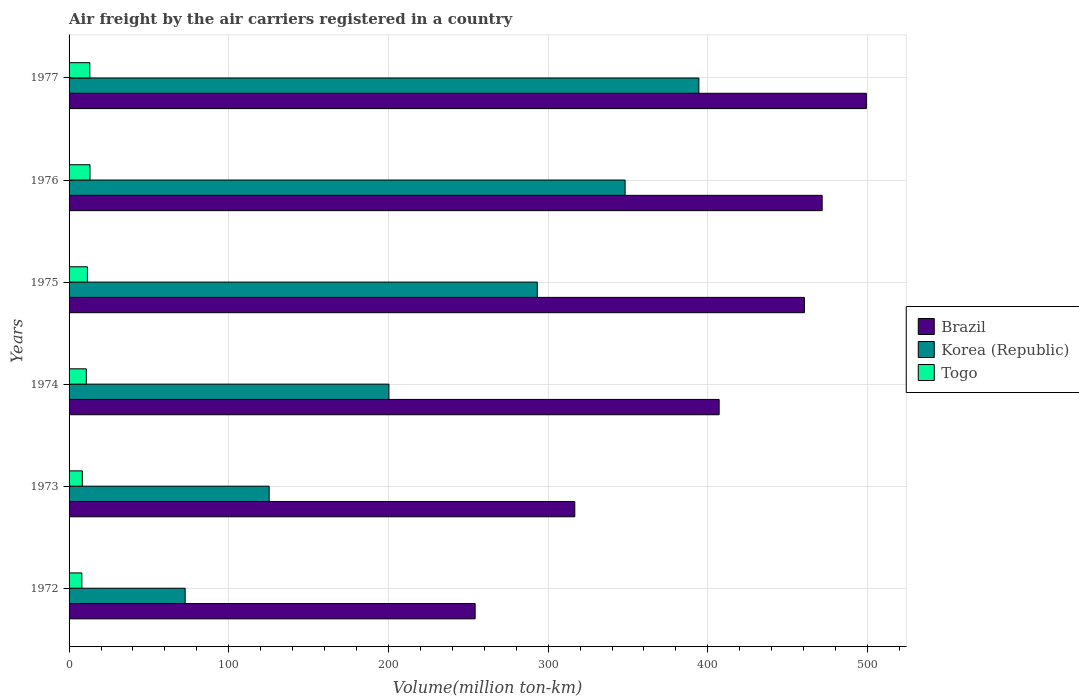How many bars are there on the 4th tick from the top?
Ensure brevity in your answer.  3. How many bars are there on the 3rd tick from the bottom?
Your answer should be very brief. 3. What is the label of the 4th group of bars from the top?
Provide a short and direct response. 1974. What is the volume of the air carriers in Togo in 1976?
Give a very brief answer. 13.1. Across all years, what is the maximum volume of the air carriers in Togo?
Give a very brief answer. 13.1. Across all years, what is the minimum volume of the air carriers in Korea (Republic)?
Make the answer very short. 72.7. In which year was the volume of the air carriers in Brazil minimum?
Make the answer very short. 1972. What is the total volume of the air carriers in Korea (Republic) in the graph?
Ensure brevity in your answer.  1434.1. What is the difference between the volume of the air carriers in Korea (Republic) in 1973 and that in 1974?
Give a very brief answer. -75. What is the difference between the volume of the air carriers in Korea (Republic) in 1976 and the volume of the air carriers in Brazil in 1972?
Make the answer very short. 93.9. What is the average volume of the air carriers in Korea (Republic) per year?
Offer a very short reply. 239.02. In the year 1973, what is the difference between the volume of the air carriers in Korea (Republic) and volume of the air carriers in Brazil?
Keep it short and to the point. -191.4. What is the ratio of the volume of the air carriers in Brazil in 1974 to that in 1976?
Keep it short and to the point. 0.86. Is the volume of the air carriers in Togo in 1974 less than that in 1977?
Your answer should be compact. Yes. Is the difference between the volume of the air carriers in Korea (Republic) in 1974 and 1975 greater than the difference between the volume of the air carriers in Brazil in 1974 and 1975?
Keep it short and to the point. No. What is the difference between the highest and the second highest volume of the air carriers in Togo?
Your answer should be compact. 0.1. What is the difference between the highest and the lowest volume of the air carriers in Brazil?
Offer a terse response. 245. Is the sum of the volume of the air carriers in Korea (Republic) in 1973 and 1976 greater than the maximum volume of the air carriers in Brazil across all years?
Your answer should be compact. No. How many bars are there?
Offer a terse response. 18. Are the values on the major ticks of X-axis written in scientific E-notation?
Your answer should be very brief. No. Where does the legend appear in the graph?
Keep it short and to the point. Center right. What is the title of the graph?
Your answer should be compact. Air freight by the air carriers registered in a country. Does "Cote d'Ivoire" appear as one of the legend labels in the graph?
Provide a succinct answer. No. What is the label or title of the X-axis?
Provide a succinct answer. Volume(million ton-km). What is the label or title of the Y-axis?
Provide a short and direct response. Years. What is the Volume(million ton-km) in Brazil in 1972?
Ensure brevity in your answer.  254.3. What is the Volume(million ton-km) in Korea (Republic) in 1972?
Keep it short and to the point. 72.7. What is the Volume(million ton-km) in Togo in 1972?
Ensure brevity in your answer.  8. What is the Volume(million ton-km) in Brazil in 1973?
Give a very brief answer. 316.7. What is the Volume(million ton-km) of Korea (Republic) in 1973?
Give a very brief answer. 125.3. What is the Volume(million ton-km) of Togo in 1973?
Give a very brief answer. 8.3. What is the Volume(million ton-km) of Brazil in 1974?
Ensure brevity in your answer.  407.1. What is the Volume(million ton-km) in Korea (Republic) in 1974?
Your response must be concise. 200.3. What is the Volume(million ton-km) of Togo in 1974?
Your answer should be very brief. 10.8. What is the Volume(million ton-km) in Brazil in 1975?
Ensure brevity in your answer.  460.5. What is the Volume(million ton-km) of Korea (Republic) in 1975?
Provide a short and direct response. 293.2. What is the Volume(million ton-km) in Togo in 1975?
Keep it short and to the point. 11.5. What is the Volume(million ton-km) in Brazil in 1976?
Provide a short and direct response. 471.6. What is the Volume(million ton-km) in Korea (Republic) in 1976?
Provide a short and direct response. 348.2. What is the Volume(million ton-km) in Togo in 1976?
Your response must be concise. 13.1. What is the Volume(million ton-km) of Brazil in 1977?
Your answer should be very brief. 499.3. What is the Volume(million ton-km) of Korea (Republic) in 1977?
Offer a terse response. 394.4. What is the Volume(million ton-km) in Togo in 1977?
Offer a terse response. 13. Across all years, what is the maximum Volume(million ton-km) of Brazil?
Your response must be concise. 499.3. Across all years, what is the maximum Volume(million ton-km) in Korea (Republic)?
Your answer should be compact. 394.4. Across all years, what is the maximum Volume(million ton-km) of Togo?
Offer a terse response. 13.1. Across all years, what is the minimum Volume(million ton-km) in Brazil?
Ensure brevity in your answer.  254.3. Across all years, what is the minimum Volume(million ton-km) of Korea (Republic)?
Give a very brief answer. 72.7. What is the total Volume(million ton-km) in Brazil in the graph?
Provide a succinct answer. 2409.5. What is the total Volume(million ton-km) in Korea (Republic) in the graph?
Ensure brevity in your answer.  1434.1. What is the total Volume(million ton-km) of Togo in the graph?
Offer a very short reply. 64.7. What is the difference between the Volume(million ton-km) in Brazil in 1972 and that in 1973?
Your response must be concise. -62.4. What is the difference between the Volume(million ton-km) in Korea (Republic) in 1972 and that in 1973?
Your answer should be compact. -52.6. What is the difference between the Volume(million ton-km) in Brazil in 1972 and that in 1974?
Your answer should be compact. -152.8. What is the difference between the Volume(million ton-km) in Korea (Republic) in 1972 and that in 1974?
Make the answer very short. -127.6. What is the difference between the Volume(million ton-km) of Togo in 1972 and that in 1974?
Your response must be concise. -2.8. What is the difference between the Volume(million ton-km) in Brazil in 1972 and that in 1975?
Offer a terse response. -206.2. What is the difference between the Volume(million ton-km) in Korea (Republic) in 1972 and that in 1975?
Your answer should be compact. -220.5. What is the difference between the Volume(million ton-km) in Togo in 1972 and that in 1975?
Provide a succinct answer. -3.5. What is the difference between the Volume(million ton-km) of Brazil in 1972 and that in 1976?
Provide a succinct answer. -217.3. What is the difference between the Volume(million ton-km) in Korea (Republic) in 1972 and that in 1976?
Your answer should be compact. -275.5. What is the difference between the Volume(million ton-km) in Brazil in 1972 and that in 1977?
Your answer should be compact. -245. What is the difference between the Volume(million ton-km) in Korea (Republic) in 1972 and that in 1977?
Provide a succinct answer. -321.7. What is the difference between the Volume(million ton-km) of Togo in 1972 and that in 1977?
Keep it short and to the point. -5. What is the difference between the Volume(million ton-km) in Brazil in 1973 and that in 1974?
Make the answer very short. -90.4. What is the difference between the Volume(million ton-km) of Korea (Republic) in 1973 and that in 1974?
Offer a terse response. -75. What is the difference between the Volume(million ton-km) in Togo in 1973 and that in 1974?
Your answer should be compact. -2.5. What is the difference between the Volume(million ton-km) of Brazil in 1973 and that in 1975?
Offer a terse response. -143.8. What is the difference between the Volume(million ton-km) in Korea (Republic) in 1973 and that in 1975?
Make the answer very short. -167.9. What is the difference between the Volume(million ton-km) in Togo in 1973 and that in 1975?
Offer a very short reply. -3.2. What is the difference between the Volume(million ton-km) in Brazil in 1973 and that in 1976?
Your answer should be compact. -154.9. What is the difference between the Volume(million ton-km) of Korea (Republic) in 1973 and that in 1976?
Your response must be concise. -222.9. What is the difference between the Volume(million ton-km) in Togo in 1973 and that in 1976?
Ensure brevity in your answer.  -4.8. What is the difference between the Volume(million ton-km) of Brazil in 1973 and that in 1977?
Keep it short and to the point. -182.6. What is the difference between the Volume(million ton-km) of Korea (Republic) in 1973 and that in 1977?
Your answer should be very brief. -269.1. What is the difference between the Volume(million ton-km) in Togo in 1973 and that in 1977?
Offer a terse response. -4.7. What is the difference between the Volume(million ton-km) in Brazil in 1974 and that in 1975?
Make the answer very short. -53.4. What is the difference between the Volume(million ton-km) of Korea (Republic) in 1974 and that in 1975?
Offer a terse response. -92.9. What is the difference between the Volume(million ton-km) of Togo in 1974 and that in 1975?
Your answer should be compact. -0.7. What is the difference between the Volume(million ton-km) of Brazil in 1974 and that in 1976?
Offer a terse response. -64.5. What is the difference between the Volume(million ton-km) of Korea (Republic) in 1974 and that in 1976?
Your answer should be compact. -147.9. What is the difference between the Volume(million ton-km) in Togo in 1974 and that in 1976?
Make the answer very short. -2.3. What is the difference between the Volume(million ton-km) in Brazil in 1974 and that in 1977?
Keep it short and to the point. -92.2. What is the difference between the Volume(million ton-km) of Korea (Republic) in 1974 and that in 1977?
Provide a short and direct response. -194.1. What is the difference between the Volume(million ton-km) in Brazil in 1975 and that in 1976?
Ensure brevity in your answer.  -11.1. What is the difference between the Volume(million ton-km) of Korea (Republic) in 1975 and that in 1976?
Keep it short and to the point. -55. What is the difference between the Volume(million ton-km) of Brazil in 1975 and that in 1977?
Keep it short and to the point. -38.8. What is the difference between the Volume(million ton-km) in Korea (Republic) in 1975 and that in 1977?
Your response must be concise. -101.2. What is the difference between the Volume(million ton-km) of Brazil in 1976 and that in 1977?
Give a very brief answer. -27.7. What is the difference between the Volume(million ton-km) of Korea (Republic) in 1976 and that in 1977?
Your response must be concise. -46.2. What is the difference between the Volume(million ton-km) in Brazil in 1972 and the Volume(million ton-km) in Korea (Republic) in 1973?
Your answer should be compact. 129. What is the difference between the Volume(million ton-km) of Brazil in 1972 and the Volume(million ton-km) of Togo in 1973?
Ensure brevity in your answer.  246. What is the difference between the Volume(million ton-km) of Korea (Republic) in 1972 and the Volume(million ton-km) of Togo in 1973?
Give a very brief answer. 64.4. What is the difference between the Volume(million ton-km) in Brazil in 1972 and the Volume(million ton-km) in Togo in 1974?
Offer a terse response. 243.5. What is the difference between the Volume(million ton-km) of Korea (Republic) in 1972 and the Volume(million ton-km) of Togo in 1974?
Make the answer very short. 61.9. What is the difference between the Volume(million ton-km) of Brazil in 1972 and the Volume(million ton-km) of Korea (Republic) in 1975?
Provide a short and direct response. -38.9. What is the difference between the Volume(million ton-km) in Brazil in 1972 and the Volume(million ton-km) in Togo in 1975?
Offer a very short reply. 242.8. What is the difference between the Volume(million ton-km) of Korea (Republic) in 1972 and the Volume(million ton-km) of Togo in 1975?
Provide a succinct answer. 61.2. What is the difference between the Volume(million ton-km) of Brazil in 1972 and the Volume(million ton-km) of Korea (Republic) in 1976?
Keep it short and to the point. -93.9. What is the difference between the Volume(million ton-km) in Brazil in 1972 and the Volume(million ton-km) in Togo in 1976?
Offer a very short reply. 241.2. What is the difference between the Volume(million ton-km) in Korea (Republic) in 1972 and the Volume(million ton-km) in Togo in 1976?
Give a very brief answer. 59.6. What is the difference between the Volume(million ton-km) in Brazil in 1972 and the Volume(million ton-km) in Korea (Republic) in 1977?
Offer a very short reply. -140.1. What is the difference between the Volume(million ton-km) in Brazil in 1972 and the Volume(million ton-km) in Togo in 1977?
Give a very brief answer. 241.3. What is the difference between the Volume(million ton-km) of Korea (Republic) in 1972 and the Volume(million ton-km) of Togo in 1977?
Your response must be concise. 59.7. What is the difference between the Volume(million ton-km) in Brazil in 1973 and the Volume(million ton-km) in Korea (Republic) in 1974?
Offer a very short reply. 116.4. What is the difference between the Volume(million ton-km) of Brazil in 1973 and the Volume(million ton-km) of Togo in 1974?
Offer a terse response. 305.9. What is the difference between the Volume(million ton-km) in Korea (Republic) in 1973 and the Volume(million ton-km) in Togo in 1974?
Offer a very short reply. 114.5. What is the difference between the Volume(million ton-km) of Brazil in 1973 and the Volume(million ton-km) of Korea (Republic) in 1975?
Keep it short and to the point. 23.5. What is the difference between the Volume(million ton-km) of Brazil in 1973 and the Volume(million ton-km) of Togo in 1975?
Provide a short and direct response. 305.2. What is the difference between the Volume(million ton-km) in Korea (Republic) in 1973 and the Volume(million ton-km) in Togo in 1975?
Offer a very short reply. 113.8. What is the difference between the Volume(million ton-km) of Brazil in 1973 and the Volume(million ton-km) of Korea (Republic) in 1976?
Give a very brief answer. -31.5. What is the difference between the Volume(million ton-km) of Brazil in 1973 and the Volume(million ton-km) of Togo in 1976?
Ensure brevity in your answer.  303.6. What is the difference between the Volume(million ton-km) in Korea (Republic) in 1973 and the Volume(million ton-km) in Togo in 1976?
Give a very brief answer. 112.2. What is the difference between the Volume(million ton-km) in Brazil in 1973 and the Volume(million ton-km) in Korea (Republic) in 1977?
Offer a terse response. -77.7. What is the difference between the Volume(million ton-km) of Brazil in 1973 and the Volume(million ton-km) of Togo in 1977?
Your answer should be compact. 303.7. What is the difference between the Volume(million ton-km) of Korea (Republic) in 1973 and the Volume(million ton-km) of Togo in 1977?
Offer a terse response. 112.3. What is the difference between the Volume(million ton-km) in Brazil in 1974 and the Volume(million ton-km) in Korea (Republic) in 1975?
Provide a succinct answer. 113.9. What is the difference between the Volume(million ton-km) of Brazil in 1974 and the Volume(million ton-km) of Togo in 1975?
Offer a very short reply. 395.6. What is the difference between the Volume(million ton-km) of Korea (Republic) in 1974 and the Volume(million ton-km) of Togo in 1975?
Offer a terse response. 188.8. What is the difference between the Volume(million ton-km) in Brazil in 1974 and the Volume(million ton-km) in Korea (Republic) in 1976?
Offer a very short reply. 58.9. What is the difference between the Volume(million ton-km) in Brazil in 1974 and the Volume(million ton-km) in Togo in 1976?
Make the answer very short. 394. What is the difference between the Volume(million ton-km) in Korea (Republic) in 1974 and the Volume(million ton-km) in Togo in 1976?
Give a very brief answer. 187.2. What is the difference between the Volume(million ton-km) of Brazil in 1974 and the Volume(million ton-km) of Togo in 1977?
Provide a succinct answer. 394.1. What is the difference between the Volume(million ton-km) of Korea (Republic) in 1974 and the Volume(million ton-km) of Togo in 1977?
Your answer should be very brief. 187.3. What is the difference between the Volume(million ton-km) of Brazil in 1975 and the Volume(million ton-km) of Korea (Republic) in 1976?
Provide a succinct answer. 112.3. What is the difference between the Volume(million ton-km) of Brazil in 1975 and the Volume(million ton-km) of Togo in 1976?
Your response must be concise. 447.4. What is the difference between the Volume(million ton-km) of Korea (Republic) in 1975 and the Volume(million ton-km) of Togo in 1976?
Keep it short and to the point. 280.1. What is the difference between the Volume(million ton-km) of Brazil in 1975 and the Volume(million ton-km) of Korea (Republic) in 1977?
Offer a terse response. 66.1. What is the difference between the Volume(million ton-km) in Brazil in 1975 and the Volume(million ton-km) in Togo in 1977?
Offer a terse response. 447.5. What is the difference between the Volume(million ton-km) of Korea (Republic) in 1975 and the Volume(million ton-km) of Togo in 1977?
Keep it short and to the point. 280.2. What is the difference between the Volume(million ton-km) in Brazil in 1976 and the Volume(million ton-km) in Korea (Republic) in 1977?
Ensure brevity in your answer.  77.2. What is the difference between the Volume(million ton-km) of Brazil in 1976 and the Volume(million ton-km) of Togo in 1977?
Provide a short and direct response. 458.6. What is the difference between the Volume(million ton-km) of Korea (Republic) in 1976 and the Volume(million ton-km) of Togo in 1977?
Provide a succinct answer. 335.2. What is the average Volume(million ton-km) in Brazil per year?
Your response must be concise. 401.58. What is the average Volume(million ton-km) in Korea (Republic) per year?
Offer a very short reply. 239.02. What is the average Volume(million ton-km) of Togo per year?
Offer a very short reply. 10.78. In the year 1972, what is the difference between the Volume(million ton-km) in Brazil and Volume(million ton-km) in Korea (Republic)?
Make the answer very short. 181.6. In the year 1972, what is the difference between the Volume(million ton-km) in Brazil and Volume(million ton-km) in Togo?
Your answer should be very brief. 246.3. In the year 1972, what is the difference between the Volume(million ton-km) in Korea (Republic) and Volume(million ton-km) in Togo?
Provide a succinct answer. 64.7. In the year 1973, what is the difference between the Volume(million ton-km) in Brazil and Volume(million ton-km) in Korea (Republic)?
Make the answer very short. 191.4. In the year 1973, what is the difference between the Volume(million ton-km) in Brazil and Volume(million ton-km) in Togo?
Give a very brief answer. 308.4. In the year 1973, what is the difference between the Volume(million ton-km) of Korea (Republic) and Volume(million ton-km) of Togo?
Your answer should be very brief. 117. In the year 1974, what is the difference between the Volume(million ton-km) of Brazil and Volume(million ton-km) of Korea (Republic)?
Your answer should be compact. 206.8. In the year 1974, what is the difference between the Volume(million ton-km) in Brazil and Volume(million ton-km) in Togo?
Ensure brevity in your answer.  396.3. In the year 1974, what is the difference between the Volume(million ton-km) in Korea (Republic) and Volume(million ton-km) in Togo?
Make the answer very short. 189.5. In the year 1975, what is the difference between the Volume(million ton-km) of Brazil and Volume(million ton-km) of Korea (Republic)?
Your answer should be very brief. 167.3. In the year 1975, what is the difference between the Volume(million ton-km) of Brazil and Volume(million ton-km) of Togo?
Make the answer very short. 449. In the year 1975, what is the difference between the Volume(million ton-km) of Korea (Republic) and Volume(million ton-km) of Togo?
Make the answer very short. 281.7. In the year 1976, what is the difference between the Volume(million ton-km) of Brazil and Volume(million ton-km) of Korea (Republic)?
Provide a short and direct response. 123.4. In the year 1976, what is the difference between the Volume(million ton-km) in Brazil and Volume(million ton-km) in Togo?
Your answer should be very brief. 458.5. In the year 1976, what is the difference between the Volume(million ton-km) in Korea (Republic) and Volume(million ton-km) in Togo?
Ensure brevity in your answer.  335.1. In the year 1977, what is the difference between the Volume(million ton-km) in Brazil and Volume(million ton-km) in Korea (Republic)?
Offer a terse response. 104.9. In the year 1977, what is the difference between the Volume(million ton-km) of Brazil and Volume(million ton-km) of Togo?
Provide a short and direct response. 486.3. In the year 1977, what is the difference between the Volume(million ton-km) of Korea (Republic) and Volume(million ton-km) of Togo?
Give a very brief answer. 381.4. What is the ratio of the Volume(million ton-km) of Brazil in 1972 to that in 1973?
Your answer should be compact. 0.8. What is the ratio of the Volume(million ton-km) in Korea (Republic) in 1972 to that in 1973?
Your answer should be very brief. 0.58. What is the ratio of the Volume(million ton-km) in Togo in 1972 to that in 1973?
Offer a terse response. 0.96. What is the ratio of the Volume(million ton-km) in Brazil in 1972 to that in 1974?
Your answer should be compact. 0.62. What is the ratio of the Volume(million ton-km) in Korea (Republic) in 1972 to that in 1974?
Your response must be concise. 0.36. What is the ratio of the Volume(million ton-km) of Togo in 1972 to that in 1974?
Ensure brevity in your answer.  0.74. What is the ratio of the Volume(million ton-km) in Brazil in 1972 to that in 1975?
Your answer should be very brief. 0.55. What is the ratio of the Volume(million ton-km) in Korea (Republic) in 1972 to that in 1975?
Give a very brief answer. 0.25. What is the ratio of the Volume(million ton-km) in Togo in 1972 to that in 1975?
Offer a terse response. 0.7. What is the ratio of the Volume(million ton-km) in Brazil in 1972 to that in 1976?
Give a very brief answer. 0.54. What is the ratio of the Volume(million ton-km) in Korea (Republic) in 1972 to that in 1976?
Keep it short and to the point. 0.21. What is the ratio of the Volume(million ton-km) in Togo in 1972 to that in 1976?
Your answer should be very brief. 0.61. What is the ratio of the Volume(million ton-km) in Brazil in 1972 to that in 1977?
Keep it short and to the point. 0.51. What is the ratio of the Volume(million ton-km) of Korea (Republic) in 1972 to that in 1977?
Provide a short and direct response. 0.18. What is the ratio of the Volume(million ton-km) of Togo in 1972 to that in 1977?
Ensure brevity in your answer.  0.62. What is the ratio of the Volume(million ton-km) of Brazil in 1973 to that in 1974?
Ensure brevity in your answer.  0.78. What is the ratio of the Volume(million ton-km) of Korea (Republic) in 1973 to that in 1974?
Provide a succinct answer. 0.63. What is the ratio of the Volume(million ton-km) of Togo in 1973 to that in 1974?
Your response must be concise. 0.77. What is the ratio of the Volume(million ton-km) in Brazil in 1973 to that in 1975?
Offer a very short reply. 0.69. What is the ratio of the Volume(million ton-km) of Korea (Republic) in 1973 to that in 1975?
Your response must be concise. 0.43. What is the ratio of the Volume(million ton-km) of Togo in 1973 to that in 1975?
Make the answer very short. 0.72. What is the ratio of the Volume(million ton-km) in Brazil in 1973 to that in 1976?
Offer a very short reply. 0.67. What is the ratio of the Volume(million ton-km) in Korea (Republic) in 1973 to that in 1976?
Offer a very short reply. 0.36. What is the ratio of the Volume(million ton-km) in Togo in 1973 to that in 1976?
Your answer should be very brief. 0.63. What is the ratio of the Volume(million ton-km) of Brazil in 1973 to that in 1977?
Ensure brevity in your answer.  0.63. What is the ratio of the Volume(million ton-km) of Korea (Republic) in 1973 to that in 1977?
Offer a terse response. 0.32. What is the ratio of the Volume(million ton-km) of Togo in 1973 to that in 1977?
Offer a very short reply. 0.64. What is the ratio of the Volume(million ton-km) of Brazil in 1974 to that in 1975?
Give a very brief answer. 0.88. What is the ratio of the Volume(million ton-km) of Korea (Republic) in 1974 to that in 1975?
Give a very brief answer. 0.68. What is the ratio of the Volume(million ton-km) in Togo in 1974 to that in 1975?
Ensure brevity in your answer.  0.94. What is the ratio of the Volume(million ton-km) of Brazil in 1974 to that in 1976?
Your answer should be very brief. 0.86. What is the ratio of the Volume(million ton-km) in Korea (Republic) in 1974 to that in 1976?
Keep it short and to the point. 0.58. What is the ratio of the Volume(million ton-km) in Togo in 1974 to that in 1976?
Provide a succinct answer. 0.82. What is the ratio of the Volume(million ton-km) in Brazil in 1974 to that in 1977?
Provide a short and direct response. 0.82. What is the ratio of the Volume(million ton-km) in Korea (Republic) in 1974 to that in 1977?
Give a very brief answer. 0.51. What is the ratio of the Volume(million ton-km) of Togo in 1974 to that in 1977?
Keep it short and to the point. 0.83. What is the ratio of the Volume(million ton-km) in Brazil in 1975 to that in 1976?
Your answer should be very brief. 0.98. What is the ratio of the Volume(million ton-km) of Korea (Republic) in 1975 to that in 1976?
Offer a very short reply. 0.84. What is the ratio of the Volume(million ton-km) of Togo in 1975 to that in 1976?
Make the answer very short. 0.88. What is the ratio of the Volume(million ton-km) in Brazil in 1975 to that in 1977?
Provide a short and direct response. 0.92. What is the ratio of the Volume(million ton-km) of Korea (Republic) in 1975 to that in 1977?
Provide a succinct answer. 0.74. What is the ratio of the Volume(million ton-km) of Togo in 1975 to that in 1977?
Ensure brevity in your answer.  0.88. What is the ratio of the Volume(million ton-km) in Brazil in 1976 to that in 1977?
Your answer should be compact. 0.94. What is the ratio of the Volume(million ton-km) of Korea (Republic) in 1976 to that in 1977?
Your answer should be compact. 0.88. What is the ratio of the Volume(million ton-km) of Togo in 1976 to that in 1977?
Provide a succinct answer. 1.01. What is the difference between the highest and the second highest Volume(million ton-km) in Brazil?
Your answer should be very brief. 27.7. What is the difference between the highest and the second highest Volume(million ton-km) of Korea (Republic)?
Make the answer very short. 46.2. What is the difference between the highest and the lowest Volume(million ton-km) of Brazil?
Your answer should be very brief. 245. What is the difference between the highest and the lowest Volume(million ton-km) of Korea (Republic)?
Give a very brief answer. 321.7. What is the difference between the highest and the lowest Volume(million ton-km) in Togo?
Your answer should be very brief. 5.1. 